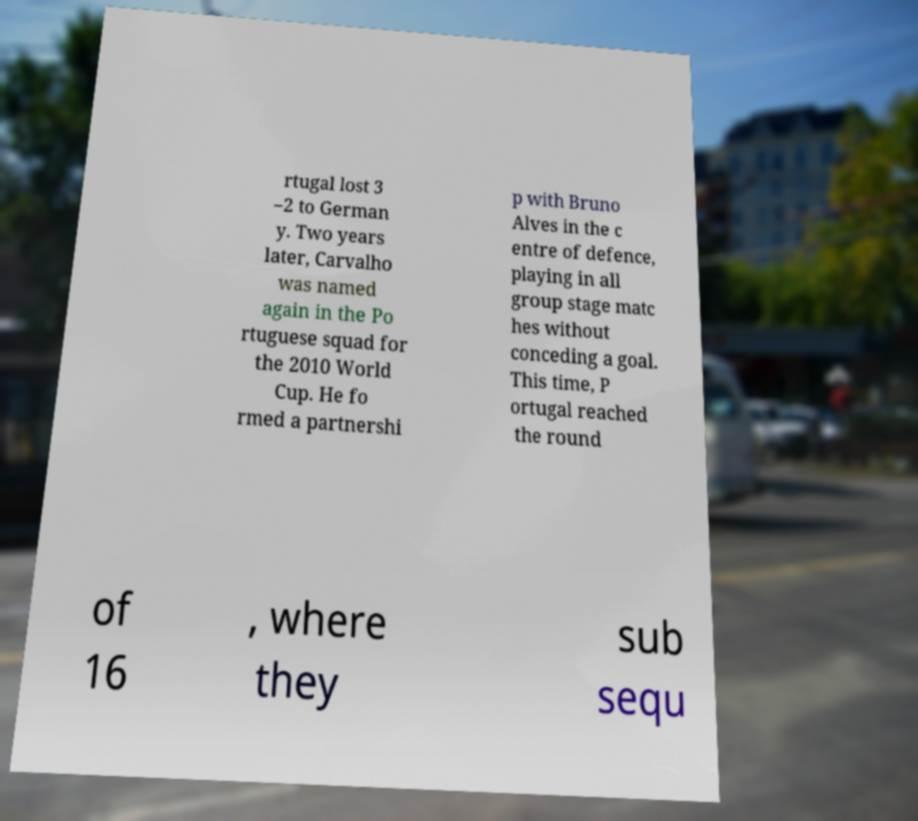I need the written content from this picture converted into text. Can you do that? rtugal lost 3 –2 to German y. Two years later, Carvalho was named again in the Po rtuguese squad for the 2010 World Cup. He fo rmed a partnershi p with Bruno Alves in the c entre of defence, playing in all group stage matc hes without conceding a goal. This time, P ortugal reached the round of 16 , where they sub sequ 